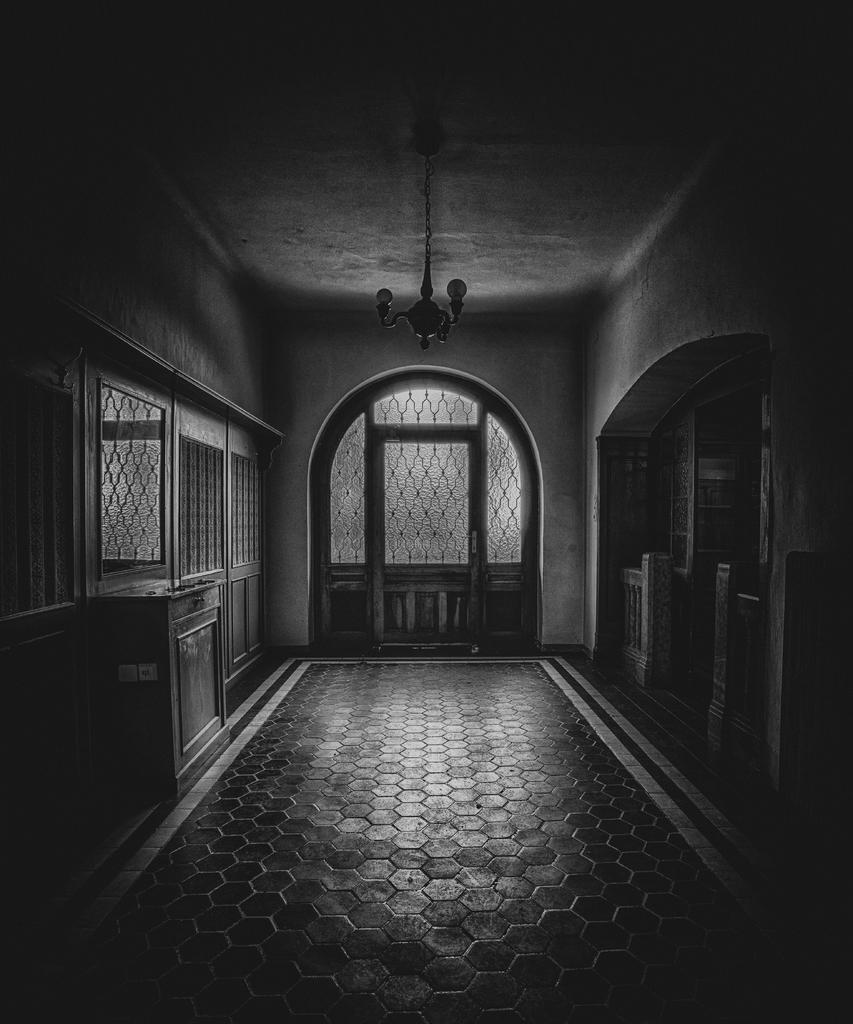Could you give a brief overview of what you see in this image? The image is in black and white, we can see there is a door, windows, there is a wall. 